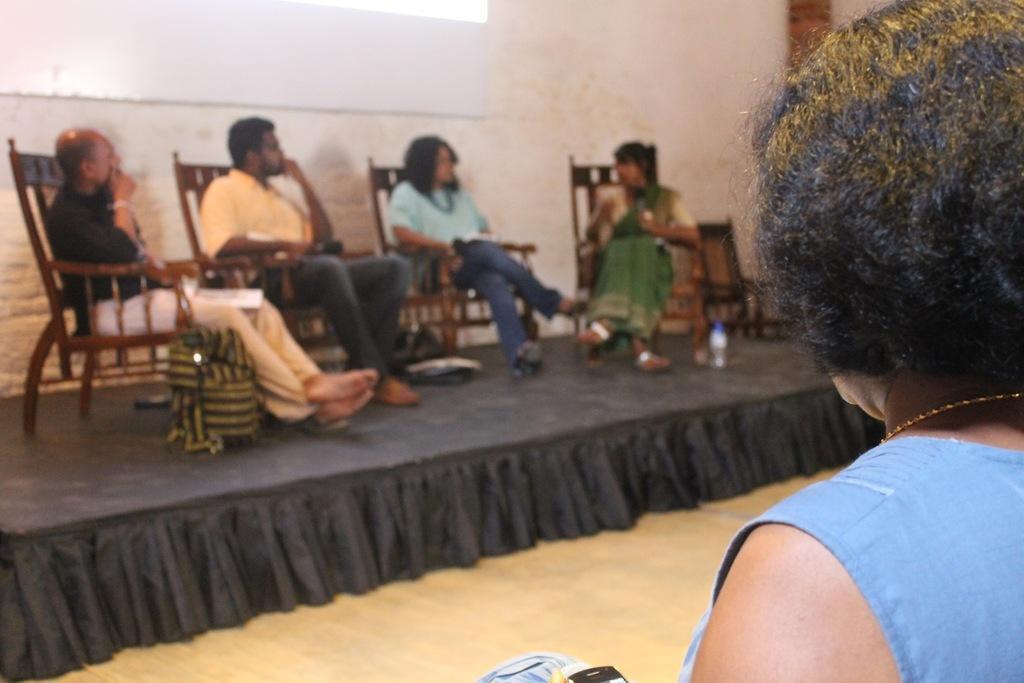Please provide a concise description of this image. There are a four people who are sitting on a chair and she is speaking with this woman and this two are observing. There is a woman on the right side. 